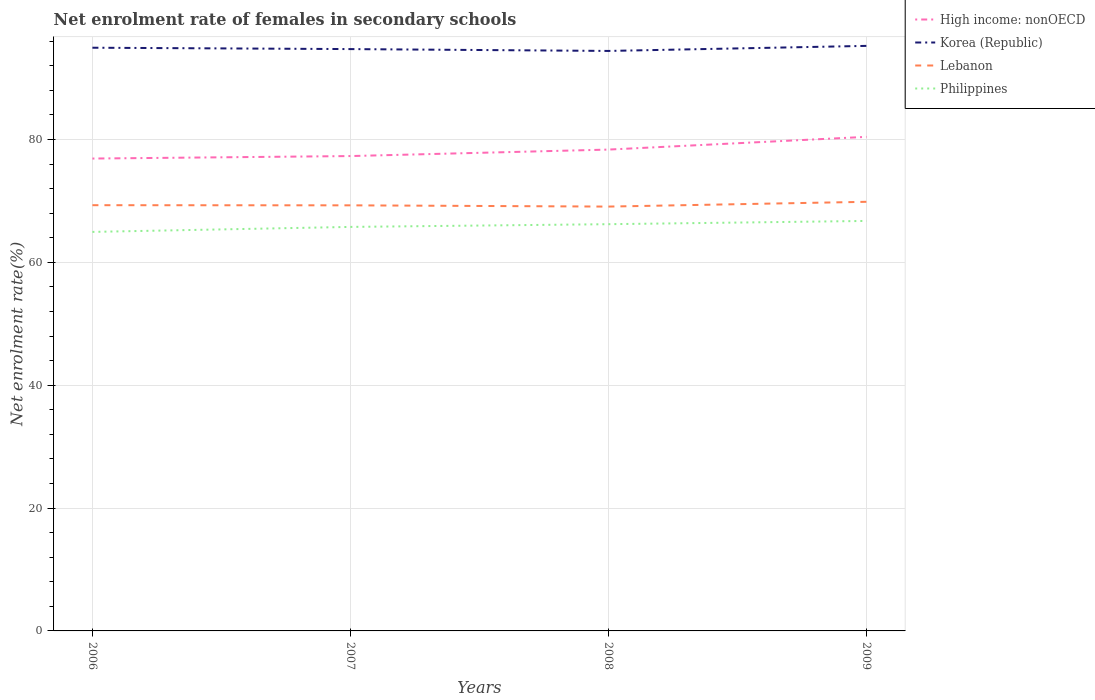Does the line corresponding to Philippines intersect with the line corresponding to Lebanon?
Offer a very short reply. No. Is the number of lines equal to the number of legend labels?
Your answer should be very brief. Yes. Across all years, what is the maximum net enrolment rate of females in secondary schools in Philippines?
Offer a very short reply. 64.96. What is the total net enrolment rate of females in secondary schools in High income: nonOECD in the graph?
Ensure brevity in your answer.  -2.07. What is the difference between the highest and the second highest net enrolment rate of females in secondary schools in Lebanon?
Provide a succinct answer. 0.78. Is the net enrolment rate of females in secondary schools in Lebanon strictly greater than the net enrolment rate of females in secondary schools in High income: nonOECD over the years?
Your answer should be very brief. Yes. How many years are there in the graph?
Ensure brevity in your answer.  4. What is the difference between two consecutive major ticks on the Y-axis?
Your answer should be very brief. 20. Does the graph contain any zero values?
Offer a terse response. No. Does the graph contain grids?
Provide a succinct answer. Yes. How are the legend labels stacked?
Provide a succinct answer. Vertical. What is the title of the graph?
Your response must be concise. Net enrolment rate of females in secondary schools. Does "Nicaragua" appear as one of the legend labels in the graph?
Provide a short and direct response. No. What is the label or title of the X-axis?
Your response must be concise. Years. What is the label or title of the Y-axis?
Your answer should be very brief. Net enrolment rate(%). What is the Net enrolment rate(%) in High income: nonOECD in 2006?
Offer a terse response. 76.9. What is the Net enrolment rate(%) of Korea (Republic) in 2006?
Provide a succinct answer. 94.94. What is the Net enrolment rate(%) of Lebanon in 2006?
Offer a very short reply. 69.31. What is the Net enrolment rate(%) of Philippines in 2006?
Offer a very short reply. 64.96. What is the Net enrolment rate(%) in High income: nonOECD in 2007?
Offer a terse response. 77.3. What is the Net enrolment rate(%) in Korea (Republic) in 2007?
Make the answer very short. 94.72. What is the Net enrolment rate(%) in Lebanon in 2007?
Your answer should be very brief. 69.28. What is the Net enrolment rate(%) of Philippines in 2007?
Your answer should be very brief. 65.77. What is the Net enrolment rate(%) of High income: nonOECD in 2008?
Your answer should be very brief. 78.36. What is the Net enrolment rate(%) in Korea (Republic) in 2008?
Keep it short and to the point. 94.42. What is the Net enrolment rate(%) in Lebanon in 2008?
Offer a very short reply. 69.08. What is the Net enrolment rate(%) of Philippines in 2008?
Your answer should be compact. 66.21. What is the Net enrolment rate(%) of High income: nonOECD in 2009?
Offer a terse response. 80.43. What is the Net enrolment rate(%) in Korea (Republic) in 2009?
Offer a terse response. 95.24. What is the Net enrolment rate(%) of Lebanon in 2009?
Provide a succinct answer. 69.86. What is the Net enrolment rate(%) in Philippines in 2009?
Make the answer very short. 66.74. Across all years, what is the maximum Net enrolment rate(%) of High income: nonOECD?
Your response must be concise. 80.43. Across all years, what is the maximum Net enrolment rate(%) in Korea (Republic)?
Your answer should be compact. 95.24. Across all years, what is the maximum Net enrolment rate(%) of Lebanon?
Provide a short and direct response. 69.86. Across all years, what is the maximum Net enrolment rate(%) of Philippines?
Provide a short and direct response. 66.74. Across all years, what is the minimum Net enrolment rate(%) in High income: nonOECD?
Provide a short and direct response. 76.9. Across all years, what is the minimum Net enrolment rate(%) in Korea (Republic)?
Your answer should be compact. 94.42. Across all years, what is the minimum Net enrolment rate(%) in Lebanon?
Provide a short and direct response. 69.08. Across all years, what is the minimum Net enrolment rate(%) in Philippines?
Provide a succinct answer. 64.96. What is the total Net enrolment rate(%) of High income: nonOECD in the graph?
Your answer should be compact. 312.99. What is the total Net enrolment rate(%) of Korea (Republic) in the graph?
Offer a terse response. 379.32. What is the total Net enrolment rate(%) in Lebanon in the graph?
Offer a very short reply. 277.52. What is the total Net enrolment rate(%) of Philippines in the graph?
Your response must be concise. 263.68. What is the difference between the Net enrolment rate(%) in High income: nonOECD in 2006 and that in 2007?
Your response must be concise. -0.4. What is the difference between the Net enrolment rate(%) in Korea (Republic) in 2006 and that in 2007?
Make the answer very short. 0.22. What is the difference between the Net enrolment rate(%) in Lebanon in 2006 and that in 2007?
Your answer should be very brief. 0.02. What is the difference between the Net enrolment rate(%) in Philippines in 2006 and that in 2007?
Provide a succinct answer. -0.81. What is the difference between the Net enrolment rate(%) in High income: nonOECD in 2006 and that in 2008?
Ensure brevity in your answer.  -1.46. What is the difference between the Net enrolment rate(%) in Korea (Republic) in 2006 and that in 2008?
Make the answer very short. 0.52. What is the difference between the Net enrolment rate(%) of Lebanon in 2006 and that in 2008?
Offer a terse response. 0.23. What is the difference between the Net enrolment rate(%) in Philippines in 2006 and that in 2008?
Provide a short and direct response. -1.26. What is the difference between the Net enrolment rate(%) in High income: nonOECD in 2006 and that in 2009?
Provide a short and direct response. -3.53. What is the difference between the Net enrolment rate(%) of Korea (Republic) in 2006 and that in 2009?
Your answer should be very brief. -0.3. What is the difference between the Net enrolment rate(%) in Lebanon in 2006 and that in 2009?
Provide a short and direct response. -0.55. What is the difference between the Net enrolment rate(%) of Philippines in 2006 and that in 2009?
Offer a very short reply. -1.78. What is the difference between the Net enrolment rate(%) of High income: nonOECD in 2007 and that in 2008?
Provide a succinct answer. -1.06. What is the difference between the Net enrolment rate(%) of Korea (Republic) in 2007 and that in 2008?
Your answer should be compact. 0.3. What is the difference between the Net enrolment rate(%) in Lebanon in 2007 and that in 2008?
Your answer should be compact. 0.2. What is the difference between the Net enrolment rate(%) in Philippines in 2007 and that in 2008?
Provide a succinct answer. -0.44. What is the difference between the Net enrolment rate(%) of High income: nonOECD in 2007 and that in 2009?
Make the answer very short. -3.13. What is the difference between the Net enrolment rate(%) in Korea (Republic) in 2007 and that in 2009?
Ensure brevity in your answer.  -0.52. What is the difference between the Net enrolment rate(%) of Lebanon in 2007 and that in 2009?
Keep it short and to the point. -0.58. What is the difference between the Net enrolment rate(%) in Philippines in 2007 and that in 2009?
Give a very brief answer. -0.97. What is the difference between the Net enrolment rate(%) in High income: nonOECD in 2008 and that in 2009?
Keep it short and to the point. -2.07. What is the difference between the Net enrolment rate(%) of Korea (Republic) in 2008 and that in 2009?
Ensure brevity in your answer.  -0.82. What is the difference between the Net enrolment rate(%) in Lebanon in 2008 and that in 2009?
Your answer should be very brief. -0.78. What is the difference between the Net enrolment rate(%) in Philippines in 2008 and that in 2009?
Keep it short and to the point. -0.53. What is the difference between the Net enrolment rate(%) of High income: nonOECD in 2006 and the Net enrolment rate(%) of Korea (Republic) in 2007?
Offer a very short reply. -17.82. What is the difference between the Net enrolment rate(%) in High income: nonOECD in 2006 and the Net enrolment rate(%) in Lebanon in 2007?
Give a very brief answer. 7.62. What is the difference between the Net enrolment rate(%) in High income: nonOECD in 2006 and the Net enrolment rate(%) in Philippines in 2007?
Ensure brevity in your answer.  11.13. What is the difference between the Net enrolment rate(%) of Korea (Republic) in 2006 and the Net enrolment rate(%) of Lebanon in 2007?
Your answer should be very brief. 25.66. What is the difference between the Net enrolment rate(%) in Korea (Republic) in 2006 and the Net enrolment rate(%) in Philippines in 2007?
Provide a succinct answer. 29.17. What is the difference between the Net enrolment rate(%) of Lebanon in 2006 and the Net enrolment rate(%) of Philippines in 2007?
Provide a succinct answer. 3.54. What is the difference between the Net enrolment rate(%) of High income: nonOECD in 2006 and the Net enrolment rate(%) of Korea (Republic) in 2008?
Provide a short and direct response. -17.52. What is the difference between the Net enrolment rate(%) in High income: nonOECD in 2006 and the Net enrolment rate(%) in Lebanon in 2008?
Your answer should be very brief. 7.82. What is the difference between the Net enrolment rate(%) of High income: nonOECD in 2006 and the Net enrolment rate(%) of Philippines in 2008?
Offer a very short reply. 10.69. What is the difference between the Net enrolment rate(%) of Korea (Republic) in 2006 and the Net enrolment rate(%) of Lebanon in 2008?
Offer a terse response. 25.86. What is the difference between the Net enrolment rate(%) of Korea (Republic) in 2006 and the Net enrolment rate(%) of Philippines in 2008?
Give a very brief answer. 28.73. What is the difference between the Net enrolment rate(%) of Lebanon in 2006 and the Net enrolment rate(%) of Philippines in 2008?
Give a very brief answer. 3.09. What is the difference between the Net enrolment rate(%) in High income: nonOECD in 2006 and the Net enrolment rate(%) in Korea (Republic) in 2009?
Your answer should be very brief. -18.34. What is the difference between the Net enrolment rate(%) in High income: nonOECD in 2006 and the Net enrolment rate(%) in Lebanon in 2009?
Provide a short and direct response. 7.04. What is the difference between the Net enrolment rate(%) in High income: nonOECD in 2006 and the Net enrolment rate(%) in Philippines in 2009?
Offer a very short reply. 10.16. What is the difference between the Net enrolment rate(%) of Korea (Republic) in 2006 and the Net enrolment rate(%) of Lebanon in 2009?
Ensure brevity in your answer.  25.08. What is the difference between the Net enrolment rate(%) in Korea (Republic) in 2006 and the Net enrolment rate(%) in Philippines in 2009?
Your answer should be very brief. 28.2. What is the difference between the Net enrolment rate(%) of Lebanon in 2006 and the Net enrolment rate(%) of Philippines in 2009?
Make the answer very short. 2.56. What is the difference between the Net enrolment rate(%) of High income: nonOECD in 2007 and the Net enrolment rate(%) of Korea (Republic) in 2008?
Ensure brevity in your answer.  -17.11. What is the difference between the Net enrolment rate(%) of High income: nonOECD in 2007 and the Net enrolment rate(%) of Lebanon in 2008?
Ensure brevity in your answer.  8.22. What is the difference between the Net enrolment rate(%) in High income: nonOECD in 2007 and the Net enrolment rate(%) in Philippines in 2008?
Your response must be concise. 11.09. What is the difference between the Net enrolment rate(%) in Korea (Republic) in 2007 and the Net enrolment rate(%) in Lebanon in 2008?
Your answer should be compact. 25.64. What is the difference between the Net enrolment rate(%) in Korea (Republic) in 2007 and the Net enrolment rate(%) in Philippines in 2008?
Provide a short and direct response. 28.51. What is the difference between the Net enrolment rate(%) in Lebanon in 2007 and the Net enrolment rate(%) in Philippines in 2008?
Ensure brevity in your answer.  3.07. What is the difference between the Net enrolment rate(%) of High income: nonOECD in 2007 and the Net enrolment rate(%) of Korea (Republic) in 2009?
Your answer should be compact. -17.94. What is the difference between the Net enrolment rate(%) in High income: nonOECD in 2007 and the Net enrolment rate(%) in Lebanon in 2009?
Offer a very short reply. 7.45. What is the difference between the Net enrolment rate(%) of High income: nonOECD in 2007 and the Net enrolment rate(%) of Philippines in 2009?
Make the answer very short. 10.56. What is the difference between the Net enrolment rate(%) of Korea (Republic) in 2007 and the Net enrolment rate(%) of Lebanon in 2009?
Make the answer very short. 24.86. What is the difference between the Net enrolment rate(%) in Korea (Republic) in 2007 and the Net enrolment rate(%) in Philippines in 2009?
Offer a very short reply. 27.98. What is the difference between the Net enrolment rate(%) in Lebanon in 2007 and the Net enrolment rate(%) in Philippines in 2009?
Your response must be concise. 2.54. What is the difference between the Net enrolment rate(%) in High income: nonOECD in 2008 and the Net enrolment rate(%) in Korea (Republic) in 2009?
Provide a succinct answer. -16.88. What is the difference between the Net enrolment rate(%) in High income: nonOECD in 2008 and the Net enrolment rate(%) in Lebanon in 2009?
Ensure brevity in your answer.  8.5. What is the difference between the Net enrolment rate(%) in High income: nonOECD in 2008 and the Net enrolment rate(%) in Philippines in 2009?
Make the answer very short. 11.62. What is the difference between the Net enrolment rate(%) in Korea (Republic) in 2008 and the Net enrolment rate(%) in Lebanon in 2009?
Make the answer very short. 24.56. What is the difference between the Net enrolment rate(%) in Korea (Republic) in 2008 and the Net enrolment rate(%) in Philippines in 2009?
Your answer should be very brief. 27.68. What is the difference between the Net enrolment rate(%) in Lebanon in 2008 and the Net enrolment rate(%) in Philippines in 2009?
Make the answer very short. 2.34. What is the average Net enrolment rate(%) in High income: nonOECD per year?
Provide a short and direct response. 78.25. What is the average Net enrolment rate(%) in Korea (Republic) per year?
Give a very brief answer. 94.83. What is the average Net enrolment rate(%) in Lebanon per year?
Give a very brief answer. 69.38. What is the average Net enrolment rate(%) in Philippines per year?
Keep it short and to the point. 65.92. In the year 2006, what is the difference between the Net enrolment rate(%) of High income: nonOECD and Net enrolment rate(%) of Korea (Republic)?
Ensure brevity in your answer.  -18.04. In the year 2006, what is the difference between the Net enrolment rate(%) of High income: nonOECD and Net enrolment rate(%) of Lebanon?
Your response must be concise. 7.59. In the year 2006, what is the difference between the Net enrolment rate(%) in High income: nonOECD and Net enrolment rate(%) in Philippines?
Give a very brief answer. 11.94. In the year 2006, what is the difference between the Net enrolment rate(%) in Korea (Republic) and Net enrolment rate(%) in Lebanon?
Offer a terse response. 25.63. In the year 2006, what is the difference between the Net enrolment rate(%) of Korea (Republic) and Net enrolment rate(%) of Philippines?
Your response must be concise. 29.98. In the year 2006, what is the difference between the Net enrolment rate(%) in Lebanon and Net enrolment rate(%) in Philippines?
Provide a short and direct response. 4.35. In the year 2007, what is the difference between the Net enrolment rate(%) in High income: nonOECD and Net enrolment rate(%) in Korea (Republic)?
Offer a terse response. -17.41. In the year 2007, what is the difference between the Net enrolment rate(%) of High income: nonOECD and Net enrolment rate(%) of Lebanon?
Offer a terse response. 8.02. In the year 2007, what is the difference between the Net enrolment rate(%) in High income: nonOECD and Net enrolment rate(%) in Philippines?
Offer a very short reply. 11.53. In the year 2007, what is the difference between the Net enrolment rate(%) in Korea (Republic) and Net enrolment rate(%) in Lebanon?
Your response must be concise. 25.44. In the year 2007, what is the difference between the Net enrolment rate(%) of Korea (Republic) and Net enrolment rate(%) of Philippines?
Offer a very short reply. 28.95. In the year 2007, what is the difference between the Net enrolment rate(%) in Lebanon and Net enrolment rate(%) in Philippines?
Provide a succinct answer. 3.51. In the year 2008, what is the difference between the Net enrolment rate(%) in High income: nonOECD and Net enrolment rate(%) in Korea (Republic)?
Give a very brief answer. -16.06. In the year 2008, what is the difference between the Net enrolment rate(%) in High income: nonOECD and Net enrolment rate(%) in Lebanon?
Ensure brevity in your answer.  9.28. In the year 2008, what is the difference between the Net enrolment rate(%) of High income: nonOECD and Net enrolment rate(%) of Philippines?
Offer a very short reply. 12.15. In the year 2008, what is the difference between the Net enrolment rate(%) of Korea (Republic) and Net enrolment rate(%) of Lebanon?
Your answer should be very brief. 25.34. In the year 2008, what is the difference between the Net enrolment rate(%) of Korea (Republic) and Net enrolment rate(%) of Philippines?
Your answer should be compact. 28.2. In the year 2008, what is the difference between the Net enrolment rate(%) of Lebanon and Net enrolment rate(%) of Philippines?
Make the answer very short. 2.87. In the year 2009, what is the difference between the Net enrolment rate(%) in High income: nonOECD and Net enrolment rate(%) in Korea (Republic)?
Your answer should be very brief. -14.81. In the year 2009, what is the difference between the Net enrolment rate(%) of High income: nonOECD and Net enrolment rate(%) of Lebanon?
Make the answer very short. 10.57. In the year 2009, what is the difference between the Net enrolment rate(%) of High income: nonOECD and Net enrolment rate(%) of Philippines?
Ensure brevity in your answer.  13.69. In the year 2009, what is the difference between the Net enrolment rate(%) of Korea (Republic) and Net enrolment rate(%) of Lebanon?
Your answer should be compact. 25.38. In the year 2009, what is the difference between the Net enrolment rate(%) in Korea (Republic) and Net enrolment rate(%) in Philippines?
Your answer should be very brief. 28.5. In the year 2009, what is the difference between the Net enrolment rate(%) in Lebanon and Net enrolment rate(%) in Philippines?
Keep it short and to the point. 3.11. What is the ratio of the Net enrolment rate(%) in Korea (Republic) in 2006 to that in 2007?
Provide a short and direct response. 1. What is the ratio of the Net enrolment rate(%) in Philippines in 2006 to that in 2007?
Ensure brevity in your answer.  0.99. What is the ratio of the Net enrolment rate(%) in High income: nonOECD in 2006 to that in 2008?
Provide a short and direct response. 0.98. What is the ratio of the Net enrolment rate(%) in Korea (Republic) in 2006 to that in 2008?
Your answer should be very brief. 1.01. What is the ratio of the Net enrolment rate(%) of High income: nonOECD in 2006 to that in 2009?
Provide a succinct answer. 0.96. What is the ratio of the Net enrolment rate(%) in Lebanon in 2006 to that in 2009?
Your response must be concise. 0.99. What is the ratio of the Net enrolment rate(%) of Philippines in 2006 to that in 2009?
Make the answer very short. 0.97. What is the ratio of the Net enrolment rate(%) in High income: nonOECD in 2007 to that in 2008?
Offer a very short reply. 0.99. What is the ratio of the Net enrolment rate(%) in Korea (Republic) in 2007 to that in 2008?
Your answer should be compact. 1. What is the ratio of the Net enrolment rate(%) in Lebanon in 2007 to that in 2008?
Provide a succinct answer. 1. What is the ratio of the Net enrolment rate(%) of High income: nonOECD in 2007 to that in 2009?
Your answer should be compact. 0.96. What is the ratio of the Net enrolment rate(%) of Korea (Republic) in 2007 to that in 2009?
Give a very brief answer. 0.99. What is the ratio of the Net enrolment rate(%) in Philippines in 2007 to that in 2009?
Make the answer very short. 0.99. What is the ratio of the Net enrolment rate(%) in High income: nonOECD in 2008 to that in 2009?
Make the answer very short. 0.97. What is the ratio of the Net enrolment rate(%) of Lebanon in 2008 to that in 2009?
Keep it short and to the point. 0.99. What is the difference between the highest and the second highest Net enrolment rate(%) in High income: nonOECD?
Your answer should be very brief. 2.07. What is the difference between the highest and the second highest Net enrolment rate(%) of Korea (Republic)?
Offer a very short reply. 0.3. What is the difference between the highest and the second highest Net enrolment rate(%) in Lebanon?
Keep it short and to the point. 0.55. What is the difference between the highest and the second highest Net enrolment rate(%) of Philippines?
Offer a very short reply. 0.53. What is the difference between the highest and the lowest Net enrolment rate(%) in High income: nonOECD?
Keep it short and to the point. 3.53. What is the difference between the highest and the lowest Net enrolment rate(%) of Korea (Republic)?
Provide a short and direct response. 0.82. What is the difference between the highest and the lowest Net enrolment rate(%) of Lebanon?
Provide a short and direct response. 0.78. What is the difference between the highest and the lowest Net enrolment rate(%) of Philippines?
Provide a short and direct response. 1.78. 